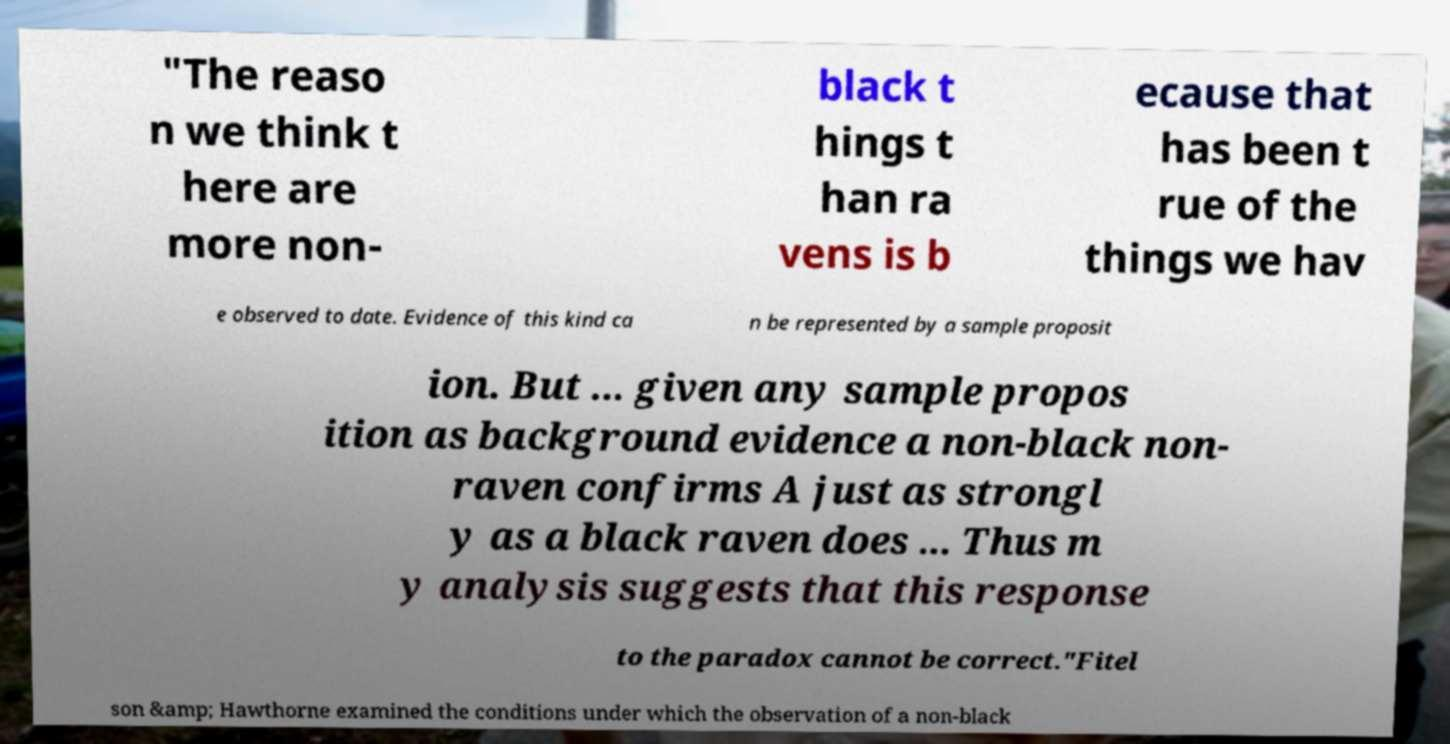I need the written content from this picture converted into text. Can you do that? "The reaso n we think t here are more non- black t hings t han ra vens is b ecause that has been t rue of the things we hav e observed to date. Evidence of this kind ca n be represented by a sample proposit ion. But ... given any sample propos ition as background evidence a non-black non- raven confirms A just as strongl y as a black raven does ... Thus m y analysis suggests that this response to the paradox cannot be correct."Fitel son &amp; Hawthorne examined the conditions under which the observation of a non-black 